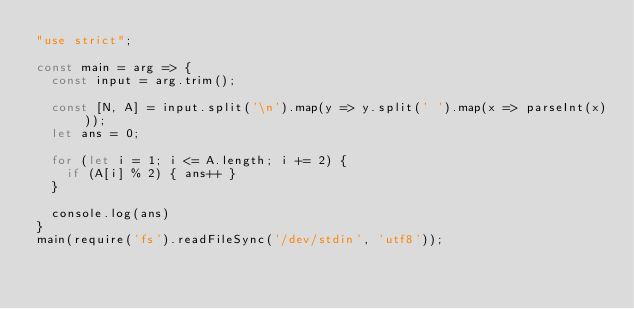<code> <loc_0><loc_0><loc_500><loc_500><_JavaScript_>"use strict";

const main = arg => {
  const input = arg.trim();

  const [N, A] = input.split('\n').map(y => y.split(' ').map(x => parseInt(x)));
  let ans = 0;

  for (let i = 1; i <= A.length; i += 2) {
    if (A[i] % 2) { ans++ }
  }

  console.log(ans)
}
main(require('fs').readFileSync('/dev/stdin', 'utf8'));</code> 